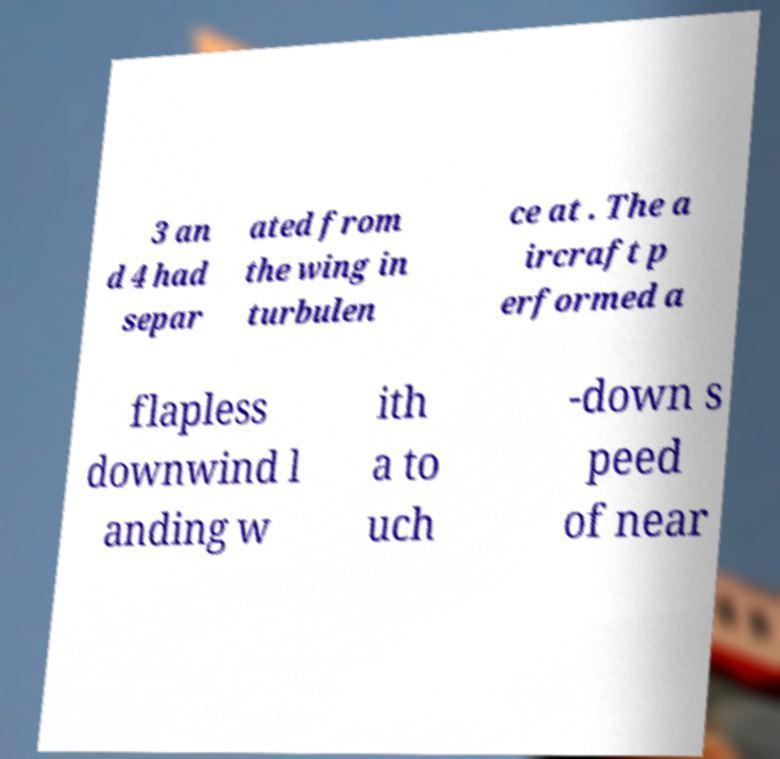Please identify and transcribe the text found in this image. 3 an d 4 had separ ated from the wing in turbulen ce at . The a ircraft p erformed a flapless downwind l anding w ith a to uch -down s peed of near 